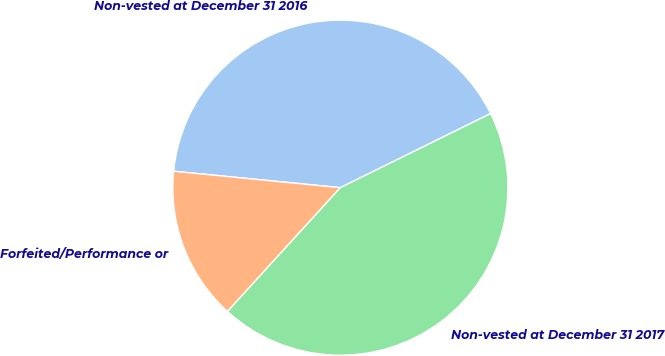Convert chart to OTSL. <chart><loc_0><loc_0><loc_500><loc_500><pie_chart><fcel>Non-vested at December 31 2016<fcel>Forfeited/Performance or<fcel>Non-vested at December 31 2017<nl><fcel>41.14%<fcel>14.8%<fcel>44.05%<nl></chart> 